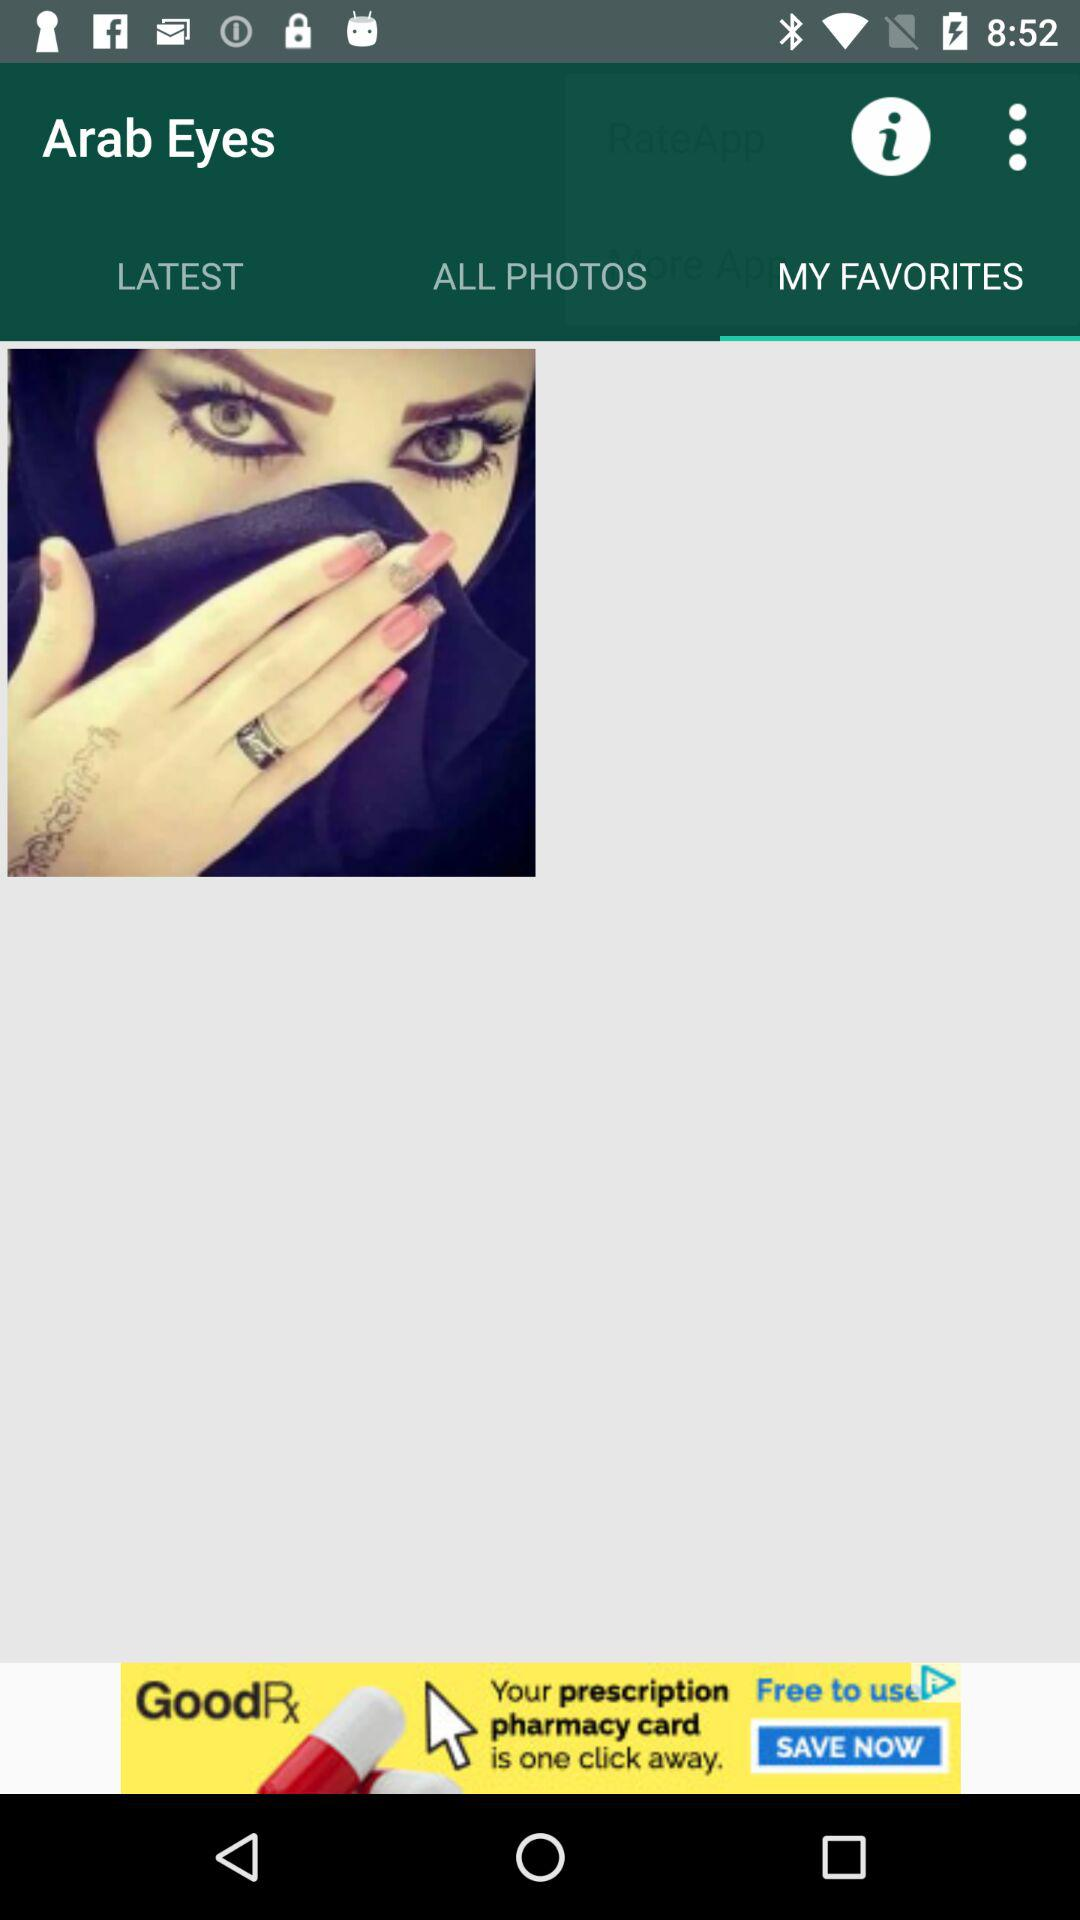Which option is selected? The selected option is "MY FAVORITES". 